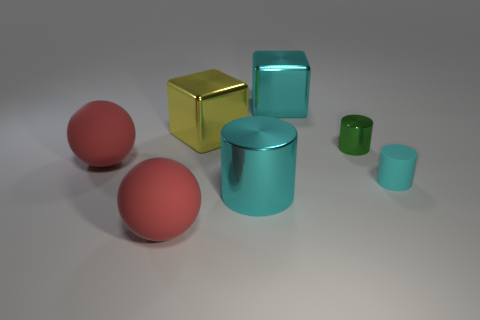How many objects are either small matte objects or matte spheres?
Provide a succinct answer. 3. What is the shape of the large object that is in front of the small rubber object and right of the large yellow cube?
Offer a very short reply. Cylinder. Are the big red thing behind the small cyan cylinder and the small cyan cylinder made of the same material?
Make the answer very short. Yes. What number of things are either big blue shiny cylinders or rubber objects on the left side of the green cylinder?
Offer a very short reply. 2. The small thing that is made of the same material as the large cylinder is what color?
Your answer should be compact. Green. How many other cylinders are made of the same material as the large cyan cylinder?
Offer a terse response. 1. What number of large metallic cubes are there?
Offer a terse response. 2. There is a object behind the yellow cube; does it have the same color as the shiny thing that is on the left side of the large cylinder?
Provide a succinct answer. No. There is a cyan metal block; how many large cyan metal cylinders are in front of it?
Ensure brevity in your answer.  1. There is a big block that is the same color as the small rubber thing; what is its material?
Your answer should be compact. Metal. 